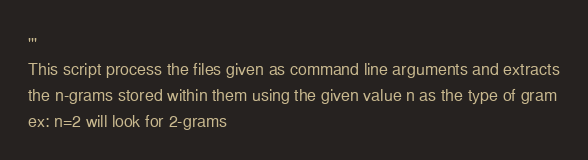<code> <loc_0><loc_0><loc_500><loc_500><_Python_>'''
This script process the files given as command line arguments and extracts
the n-grams stored within them using the given value n as the type of gram
ex: n=2 will look for 2-grams</code> 